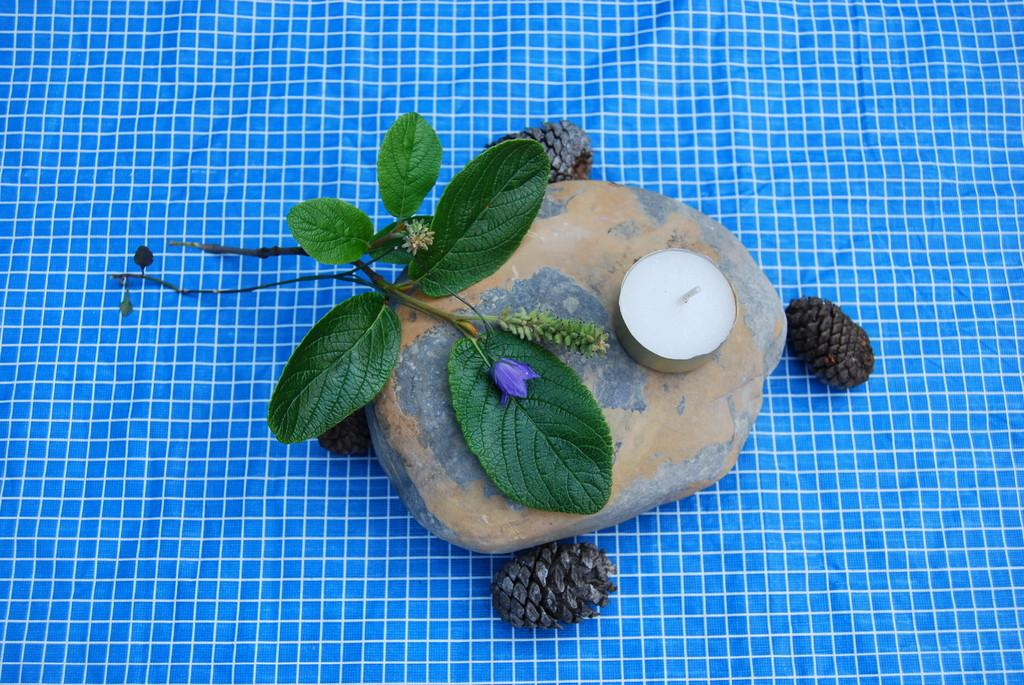What is the color and pattern of the cloth in the image? The cloth in the image is blue and white check. What is placed on the cloth? There is a stone and pine cones on the cloth. What type of plant is on the cloth? There is a plant with leaves and a flower on the cloth. What is on the stone? There is a candle on the stone. Where is the nest located in the image? There is no nest present in the image. What is the thumb doing in the image? There is no thumb present in the image. 